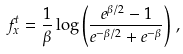<formula> <loc_0><loc_0><loc_500><loc_500>f _ { x } ^ { t } = \frac { 1 } { \beta } \log \left ( \frac { e ^ { \beta / 2 } - 1 } { e ^ { - \beta / 2 } + e ^ { - \beta } } \right ) \, ,</formula> 